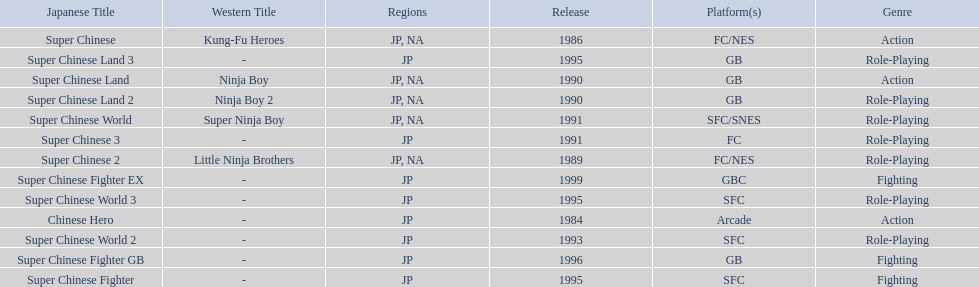Which titles were released in north america? Super Chinese, Super Chinese 2, Super Chinese Land, Super Chinese Land 2, Super Chinese World. Of those, which had the least releases? Super Chinese World. 